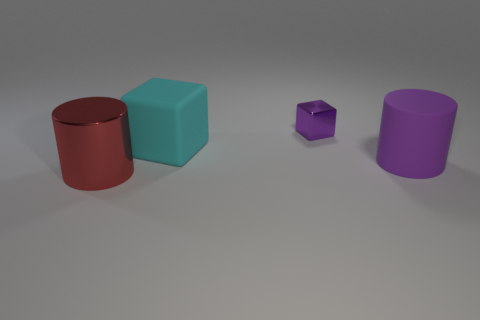Add 3 big cylinders. How many objects exist? 7 Subtract 1 purple blocks. How many objects are left? 3 Subtract all large blue cylinders. Subtract all big shiny objects. How many objects are left? 3 Add 4 red shiny cylinders. How many red shiny cylinders are left? 5 Add 3 shiny blocks. How many shiny blocks exist? 4 